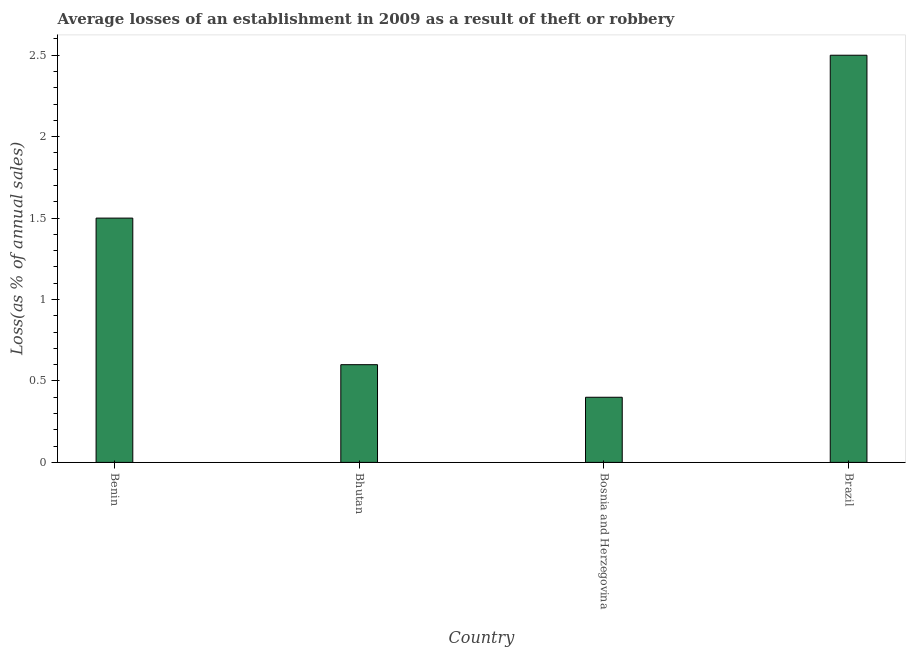Does the graph contain any zero values?
Offer a terse response. No. What is the title of the graph?
Keep it short and to the point. Average losses of an establishment in 2009 as a result of theft or robbery. What is the label or title of the X-axis?
Give a very brief answer. Country. What is the label or title of the Y-axis?
Offer a terse response. Loss(as % of annual sales). In which country was the losses due to theft maximum?
Ensure brevity in your answer.  Brazil. In which country was the losses due to theft minimum?
Your response must be concise. Bosnia and Herzegovina. What is the sum of the losses due to theft?
Ensure brevity in your answer.  5. What is the average losses due to theft per country?
Your response must be concise. 1.25. What is the ratio of the losses due to theft in Bhutan to that in Brazil?
Make the answer very short. 0.24. What is the difference between the highest and the second highest losses due to theft?
Offer a terse response. 1. How many countries are there in the graph?
Your answer should be very brief. 4. Are the values on the major ticks of Y-axis written in scientific E-notation?
Offer a very short reply. No. What is the Loss(as % of annual sales) of Bhutan?
Make the answer very short. 0.6. What is the Loss(as % of annual sales) in Bosnia and Herzegovina?
Give a very brief answer. 0.4. What is the Loss(as % of annual sales) of Brazil?
Keep it short and to the point. 2.5. What is the difference between the Loss(as % of annual sales) in Benin and Bhutan?
Keep it short and to the point. 0.9. What is the difference between the Loss(as % of annual sales) in Benin and Bosnia and Herzegovina?
Provide a short and direct response. 1.1. What is the ratio of the Loss(as % of annual sales) in Benin to that in Bosnia and Herzegovina?
Offer a terse response. 3.75. What is the ratio of the Loss(as % of annual sales) in Benin to that in Brazil?
Give a very brief answer. 0.6. What is the ratio of the Loss(as % of annual sales) in Bhutan to that in Brazil?
Provide a succinct answer. 0.24. What is the ratio of the Loss(as % of annual sales) in Bosnia and Herzegovina to that in Brazil?
Offer a terse response. 0.16. 